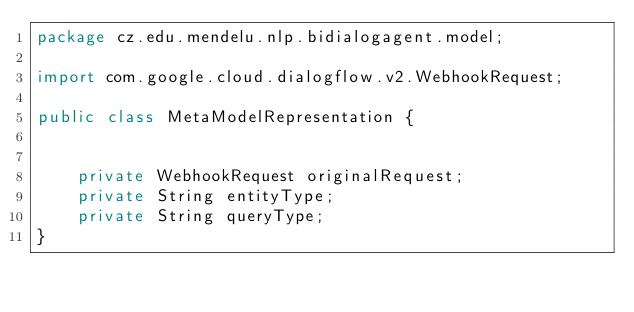Convert code to text. <code><loc_0><loc_0><loc_500><loc_500><_Java_>package cz.edu.mendelu.nlp.bidialogagent.model;

import com.google.cloud.dialogflow.v2.WebhookRequest;

public class MetaModelRepresentation {

	
	private WebhookRequest originalRequest;
	private String entityType;
	private String queryType;
}
</code> 